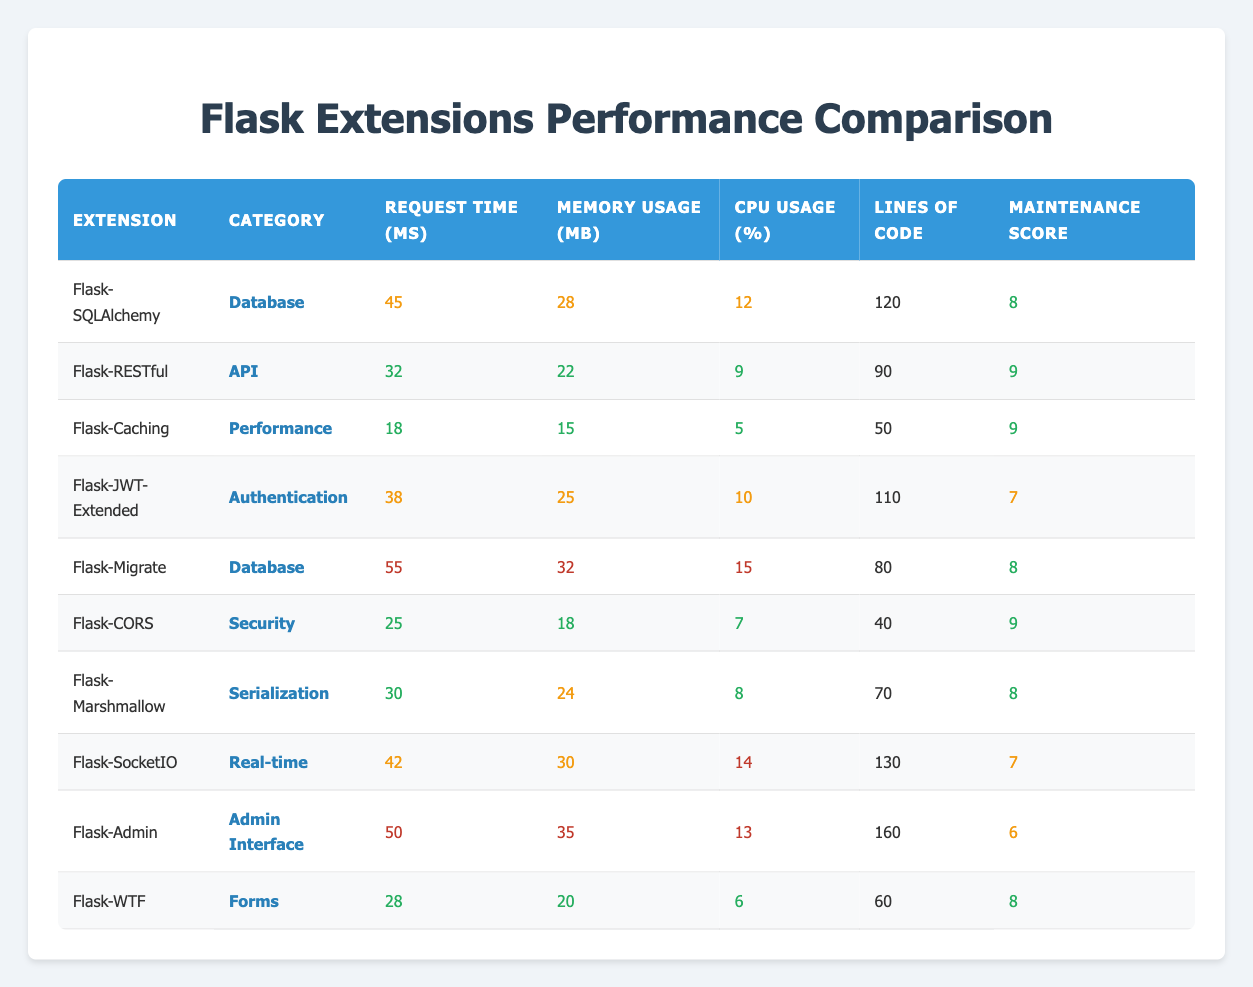What is the request time for Flask-Caching? The request time for Flask-Caching is directly listed in the table under the "Request Time (ms)" column for that extension. According to the table, it shows 18 ms.
Answer: 18 ms Which extension has the highest memory usage? By visually scanning the "Memory Usage (MB)" column, we can see that Flask-Admin has the highest memory usage, which is 35 MB.
Answer: Flask-Admin What is the average CPU usage of the database category extensions? The database category includes Flask-SQLAlchemy and Flask-Migrate. Their CPU usage values are 12% and 15%, respectively. Adding these together gives 27%. Dividing by 2 (number of extensions) gives an average of 13.5%.
Answer: 13.5% Is the maintenance score for Flask-RESTful higher than that for Flask-WTF? Flask-RESTful has a maintenance score of 9, whereas Flask-WTF has a score of 8. Since 9 is greater than 8, the statement is true.
Answer: Yes What is the difference in request time between Flask-JWT-Extended and Flask-CORS? Flask-JWT-Extended has a request time of 38 ms and Flask-CORS has a request time of 25 ms. Subtracting these values gives 13 ms.
Answer: 13 ms What is the maintenance score for Flask-SocketIO, and how does it compare to the maintenance score for Flask-Caching? The maintenance score for Flask-SocketIO is 7, while for Flask-Caching it is 9. Since 7 is less than 9, Flask-Caching has a higher maintenance score.
Answer: 7, Flask-Caching is higher How many extensions fall under the API category, and what is their average request time? There is only one extension in the API category, which is Flask-RESTful. Its request time is 32 ms. Since there's only one, the average is also 32 ms.
Answer: 32 ms Which extension has the best (lowest) request time, and what is that time? Upon reviewing the "Request Time (ms)" column, Flask-Caching has the lowest request time of 18 ms.
Answer: Flask-Caching, 18 ms What category does Flask-Migrate belong to, and what is its maintenance score? Flask-Migrate belongs to the "Database" category, and its maintenance score is 8, as shown in the respective columns.
Answer: Database, 8 